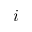<formula> <loc_0><loc_0><loc_500><loc_500>i</formula> 